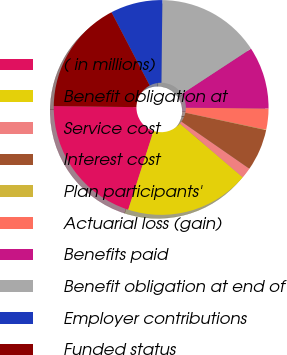<chart> <loc_0><loc_0><loc_500><loc_500><pie_chart><fcel>( in millions)<fcel>Benefit obligation at<fcel>Service cost<fcel>Interest cost<fcel>Plan participants'<fcel>Actuarial loss (gain)<fcel>Benefits paid<fcel>Benefit obligation at end of<fcel>Employer contributions<fcel>Funded status<nl><fcel>20.25%<fcel>18.7%<fcel>1.61%<fcel>6.27%<fcel>0.06%<fcel>3.17%<fcel>9.38%<fcel>15.59%<fcel>7.83%<fcel>17.14%<nl></chart> 